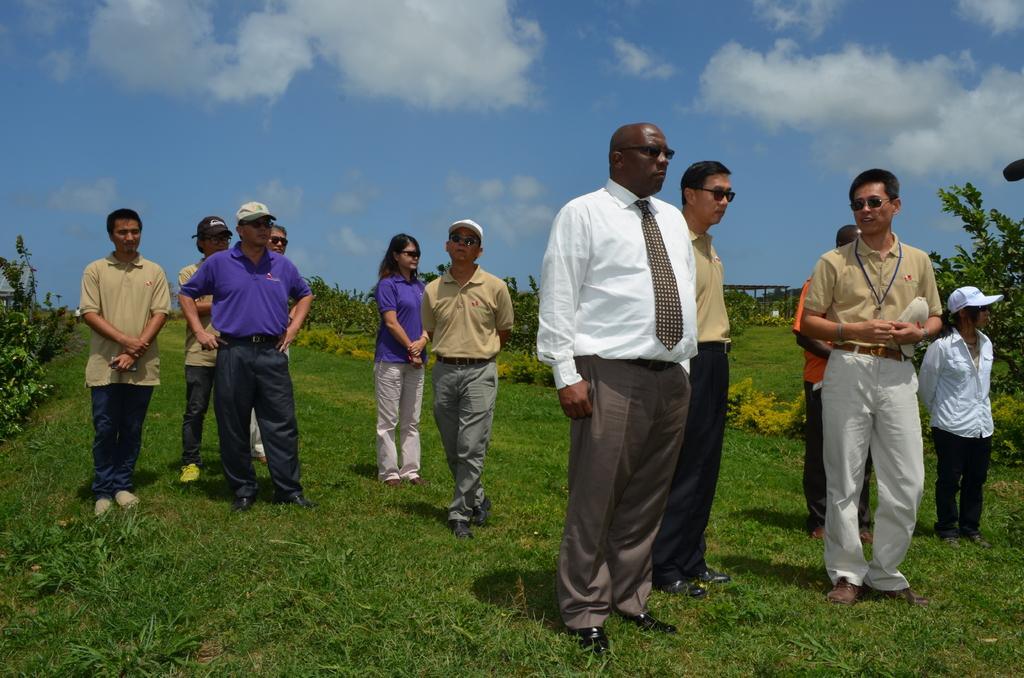In one or two sentences, can you explain what this image depicts? In this image I can see the group of people are standing on the grass. I can see few people are wearing the caps. In the background I can see the plants, sheds, clouds and the sky. 